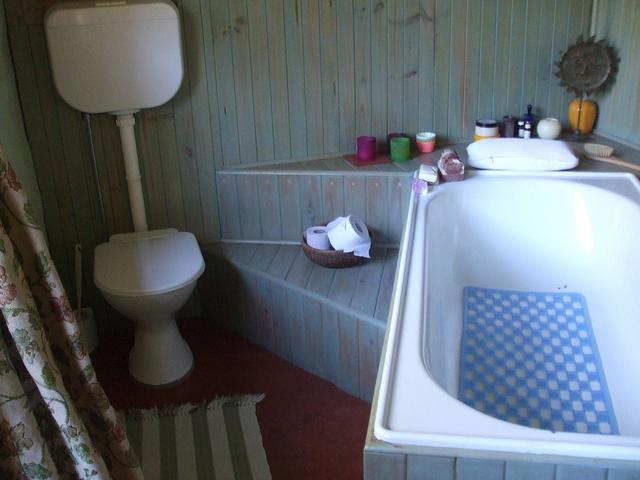What type of rolls are in the wicker basket? Please explain your reasoning. toilet. The rolls are paper that is used to wipe yourself after going to the bathroom. 